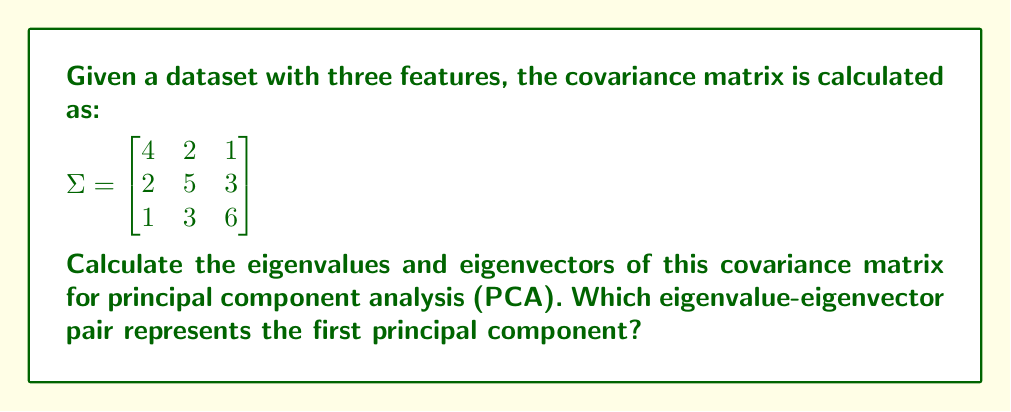Teach me how to tackle this problem. To find the eigenvalues and eigenvectors of the covariance matrix, we follow these steps:

1. Calculate the characteristic equation:
   $\det(\Sigma - \lambda I) = 0$
   
   $$\begin{vmatrix}
   4-\lambda & 2 & 1 \\
   2 & 5-\lambda & 3 \\
   1 & 3 & 6-\lambda
   \end{vmatrix} = 0$$

2. Expand the determinant:
   $-(4-\lambda)(5-\lambda)(6-\lambda) + 2\cdot3\cdot1 + 2\cdot1\cdot3 - (4-\lambda)\cdot3^2 - (5-\lambda) - (6-\lambda)\cdot2^2 = 0$
   
   $-\lambda^3 + 15\lambda^2 - 74\lambda + 120 + 6 + 6 - 36 + 9\lambda - 1 - 4\lambda + 24 - 4 = 0$
   
   $-\lambda^3 + 15\lambda^2 - 69\lambda + 115 = 0$

3. Solve the characteristic equation (using a calculator or computer algebra system):
   $\lambda_1 \approx 9.4721$
   $\lambda_2 \approx 3.8856$
   $\lambda_3 \approx 1.6423$

4. Find the eigenvectors for each eigenvalue by solving $(\Sigma - \lambda_i I)\mathbf{v}_i = \mathbf{0}$:

   For $\lambda_1 \approx 9.4721$:
   $$\begin{bmatrix}
   -5.4721 & 2 & 1 \\
   2 & -4.4721 & 3 \\
   1 & 3 & -3.4721
   \end{bmatrix}\mathbf{v}_1 = \mathbf{0}$$
   
   Solving this system yields: $\mathbf{v}_1 \approx [0.3678, 0.6015, 0.7088]^T$

   Similarly, for $\lambda_2$ and $\lambda_3$:
   $\mathbf{v}_2 \approx [-0.9044, 0.3080, 0.2955]^T$
   $\mathbf{v}_3 \approx [0.2142, -0.7385, 0.6396]^T$

5. Normalize the eigenvectors to unit length.

The first principal component is represented by the eigenvalue-eigenvector pair with the largest eigenvalue, which is $\lambda_1 \approx 9.4721$ and $\mathbf{v}_1 \approx [0.3678, 0.6015, 0.7088]^T$.
Answer: Eigenvalues: $\lambda_1 \approx 9.4721$, $\lambda_2 \approx 3.8856$, $\lambda_3 \approx 1.6423$
Eigenvectors: $\mathbf{v}_1 \approx [0.3678, 0.6015, 0.7088]^T$, $\mathbf{v}_2 \approx [-0.9044, 0.3080, 0.2955]^T$, $\mathbf{v}_3 \approx [0.2142, -0.7385, 0.6396]^T$
First principal component: $\lambda_1 \approx 9.4721$, $\mathbf{v}_1 \approx [0.3678, 0.6015, 0.7088]^T$ 